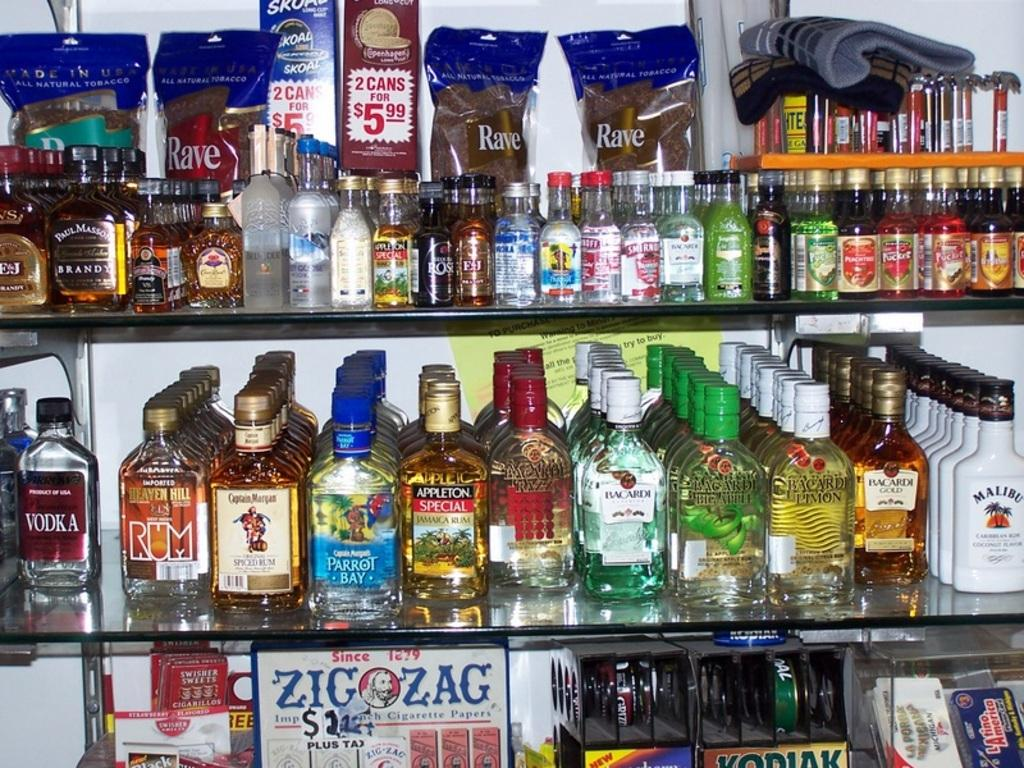What types of bottles are visible in the image? There are bottles of oil, moisturizer, shampoo, and wine in the image. What other items can be seen on the shelves in the image? There are packets of unknown items on the upper shelf in the image. How much did the person pay for the alley and bag in the image? There is no alley or bag present in the image, so it is not possible to determine any payment for them. 